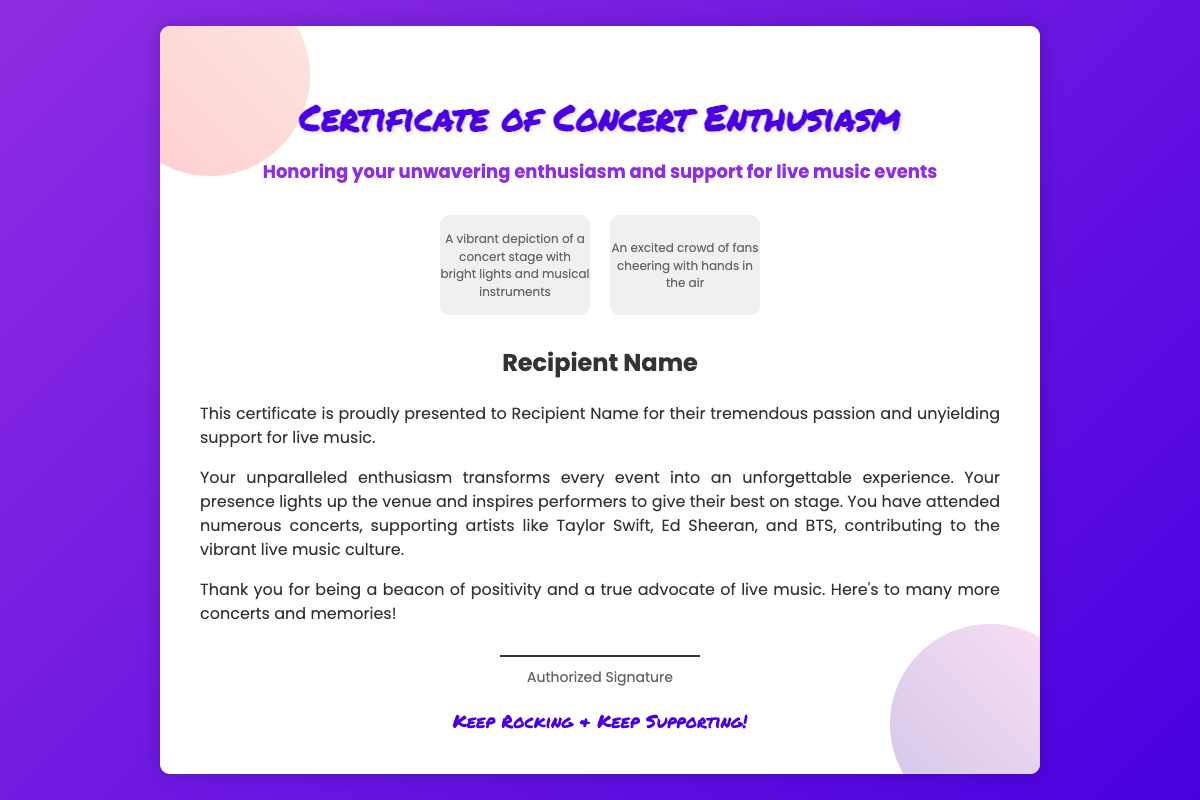What is the title of the document? The title is prominently displayed at the top of the document.
Answer: Certificate of Concert Enthusiasm What is the recipient's name placeholder? The document contains a placeholder for the recipient's name.
Answer: Recipient Name Who is the certificate honoring? The certificate honors the recipient for their enthusiasm towards live events.
Answer: Your unwavering enthusiasm and support for live music events What are the two scenes illustrated on the certificate? The document describes two specific illustrations related to a concert.
Answer: A vibrant depiction of a concert stage, an excited crowd of fans What message does the certificate convey to the recipient? The document summarizes the key message given in the body text.
Answer: Your unparalleled enthusiasm transforms every event into an unforgettable experience Which artists are mentioned as being supported by the recipient? The document lists specific artists the recipient has supported at concerts.
Answer: Taylor Swift, Ed Sheeran, and BTS What is written under the authorized signature line? The footer contains a statement encouraging continued participation in live music.
Answer: Keep Rocking & Keep Supporting! 